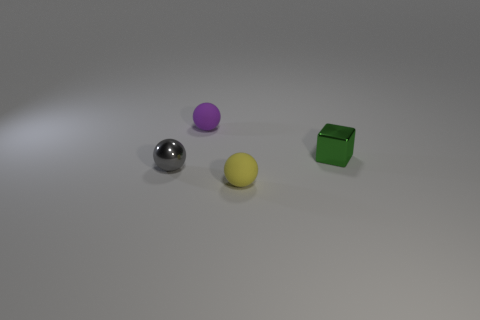Add 1 large cyan rubber spheres. How many objects exist? 5 Subtract all balls. How many objects are left? 1 Subtract 1 green blocks. How many objects are left? 3 Subtract all small cyan shiny blocks. Subtract all small yellow rubber things. How many objects are left? 3 Add 2 green shiny things. How many green shiny things are left? 3 Add 2 yellow things. How many yellow things exist? 3 